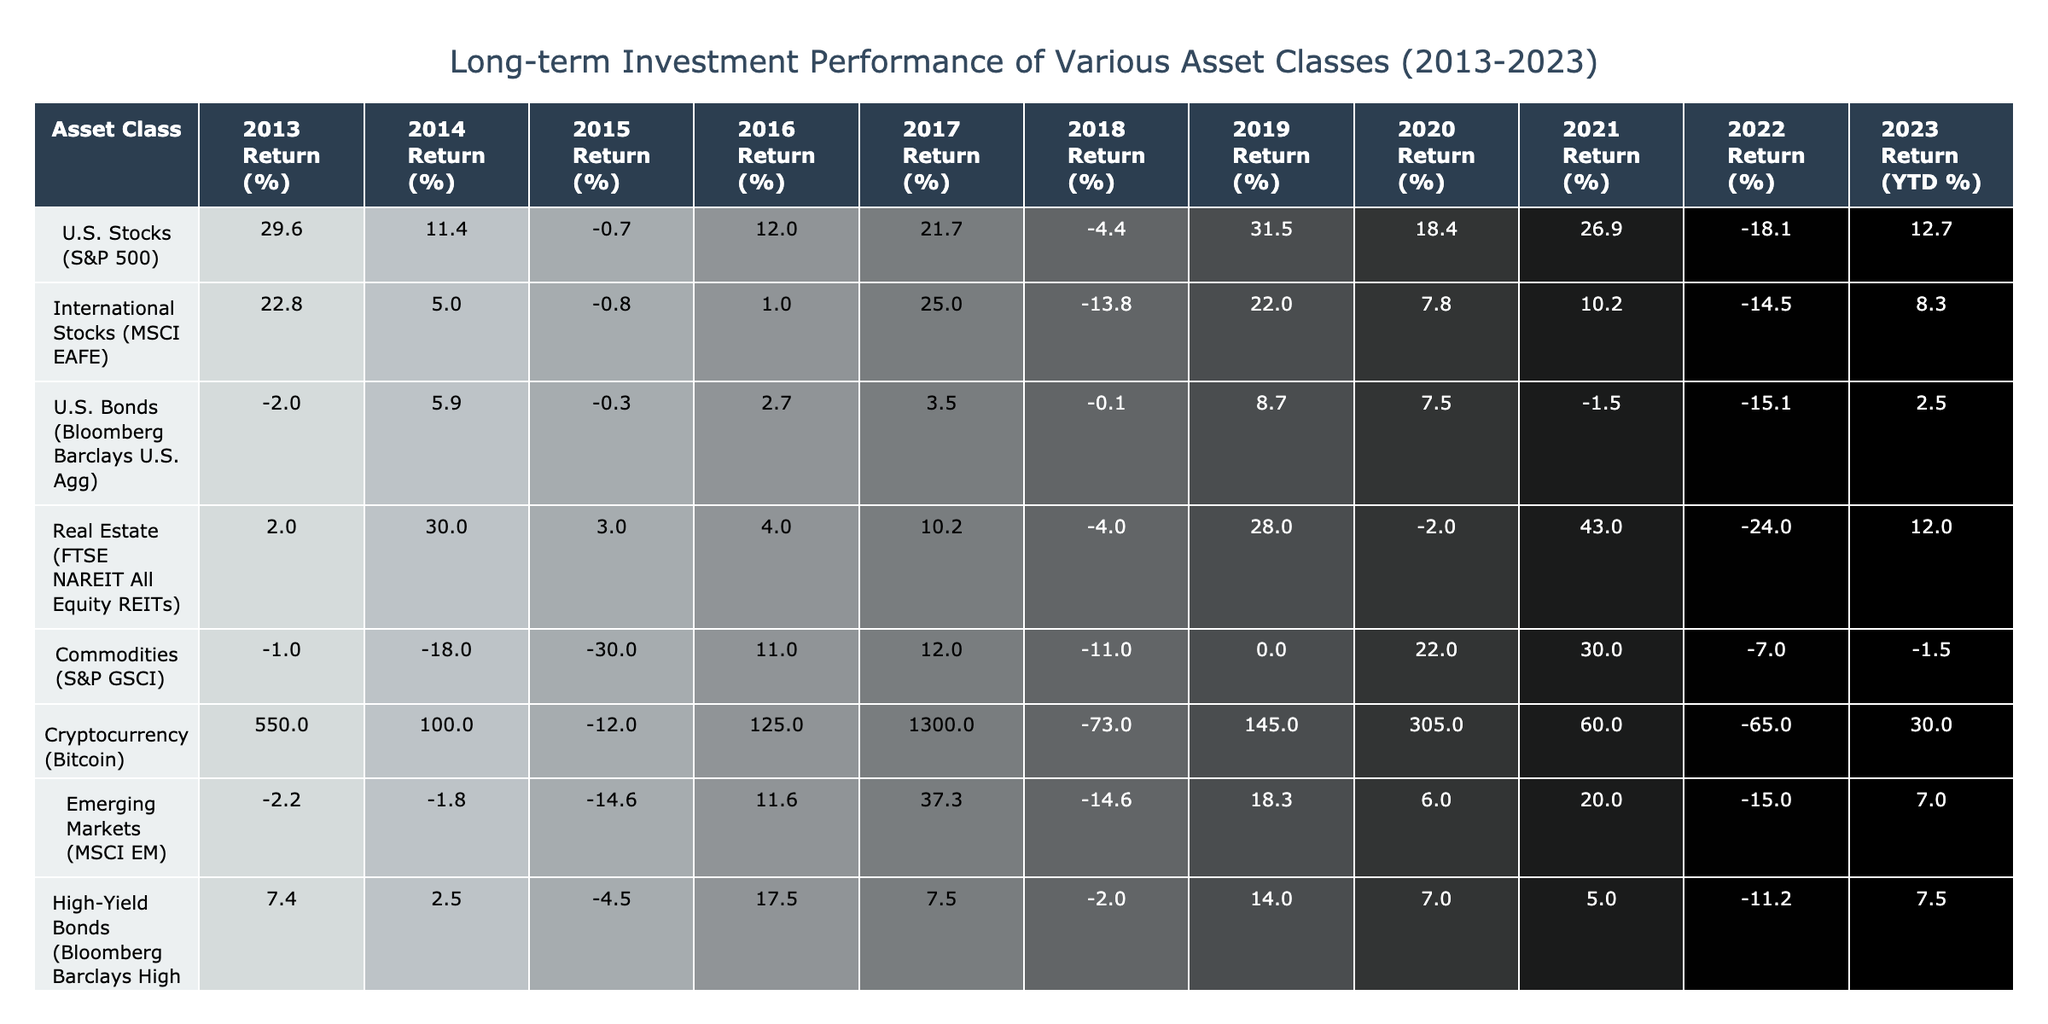What was the highest return for U.S. Stocks in a single year over the last decade? The table shows the annual returns for U.S. Stocks (S&P 500) from 2013 to 2023. Looking at the values, the highest return occurred in 2019, which was 31.5%.
Answer: 31.5% In which year did Cryptocurrency have the lowest return? The table indicates the annual returns for Cryptocurrency (Bitcoin) from 2013 to 2023. The lowest return was in 2018, which was -73.0%.
Answer: -73.0% What is the average return of Emerging Markets over the decade? To find the average, I add the returns from 2013 to 2023: (-2.2 + -1.8 + -14.6 + 11.6 + 37.3 + -14.6 + 18.3 + 6.0 + 20.0 + -15.0 + 7.0) = 6.0, and then divide by 11 (the number of years), resulting in approximately 0.5%.
Answer: 0.5% Did Real Estate produce a positive return in 2022? The table shows that the return for Real Estate in 2022 was -24.0%, which is negative. Therefore, it did not produce a positive return in that year.
Answer: No What was the combined total return for U.S. Bonds from 2013 to 2016? To find the combined return, I sum the returns for U.S. Bonds from 2013 to 2016: (-2.0 + 5.9 + -0.3 + 2.7) = 6.3%.
Answer: 6.3% Which asset class had the highest average annual return over the decade? I calculate the average annual return for each asset class. For Cryptocurrency, the average is 136.0%; for U.S. Stocks, it’s 12.7%; for Real Estate, it’s 9.1%; and so on. The highest average is for Cryptocurrency, which is 136.0%.
Answer: 136.0% What trend can be observed for U.S. Stocks in 2022 compared to 2021? In the table, the return for U.S. Stocks in 2021 was 26.9%, but it dropped to -18.1% in 2022. This indicates a significant decline in performance from one year to the next.
Answer: Decline Did International Stocks outperform U.S. Bonds in 2020? In 2020, International Stocks returned 7.8%, while U.S. Bonds returned 7.5%. Since 7.8% is greater than 7.5%, the answer is yes.
Answer: Yes What is the percentage difference between the returns of Cryptocurrency in 2017 and 2018? The return for Cryptocurrency in 2017 was 1300.0% and in 2018 it was -73.0%. The difference is calculated by subtracting the two: 1300.0 - (-73.0) = 1373.0%.
Answer: 1373.0% 